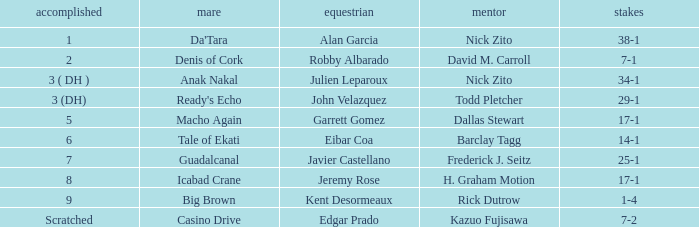Who is the Jockey for guadalcanal? Javier Castellano. 